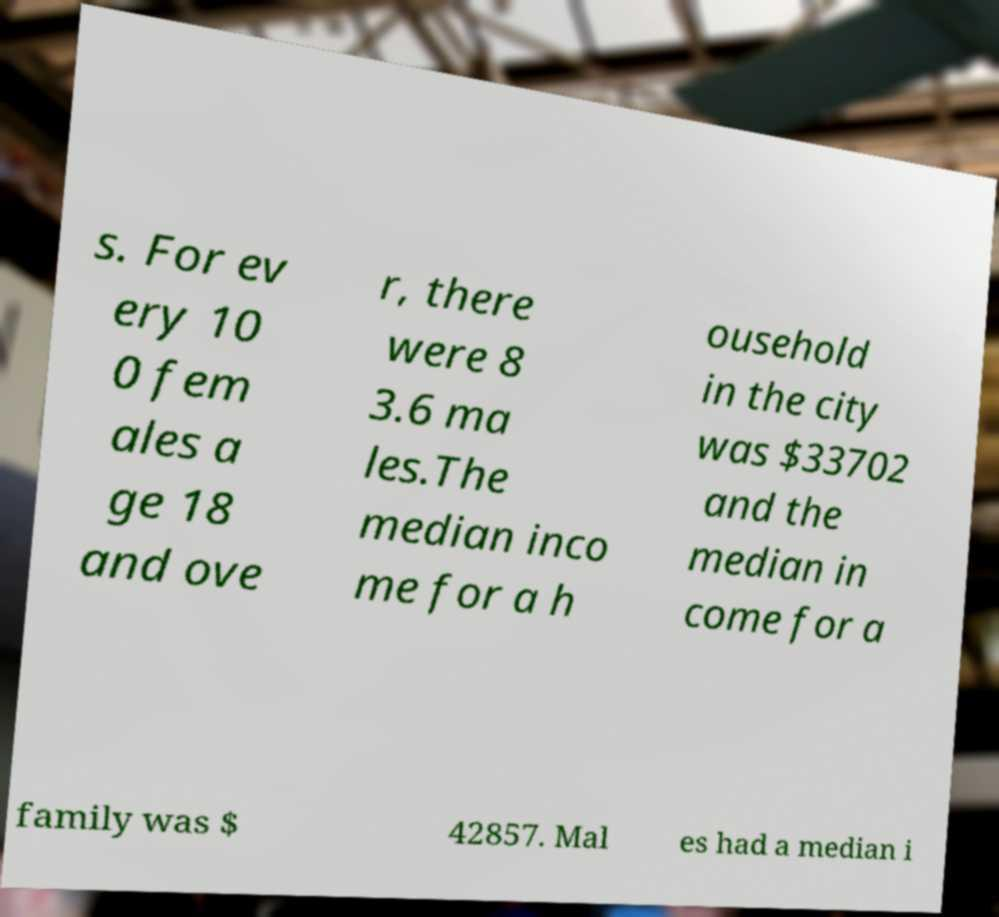Can you accurately transcribe the text from the provided image for me? s. For ev ery 10 0 fem ales a ge 18 and ove r, there were 8 3.6 ma les.The median inco me for a h ousehold in the city was $33702 and the median in come for a family was $ 42857. Mal es had a median i 